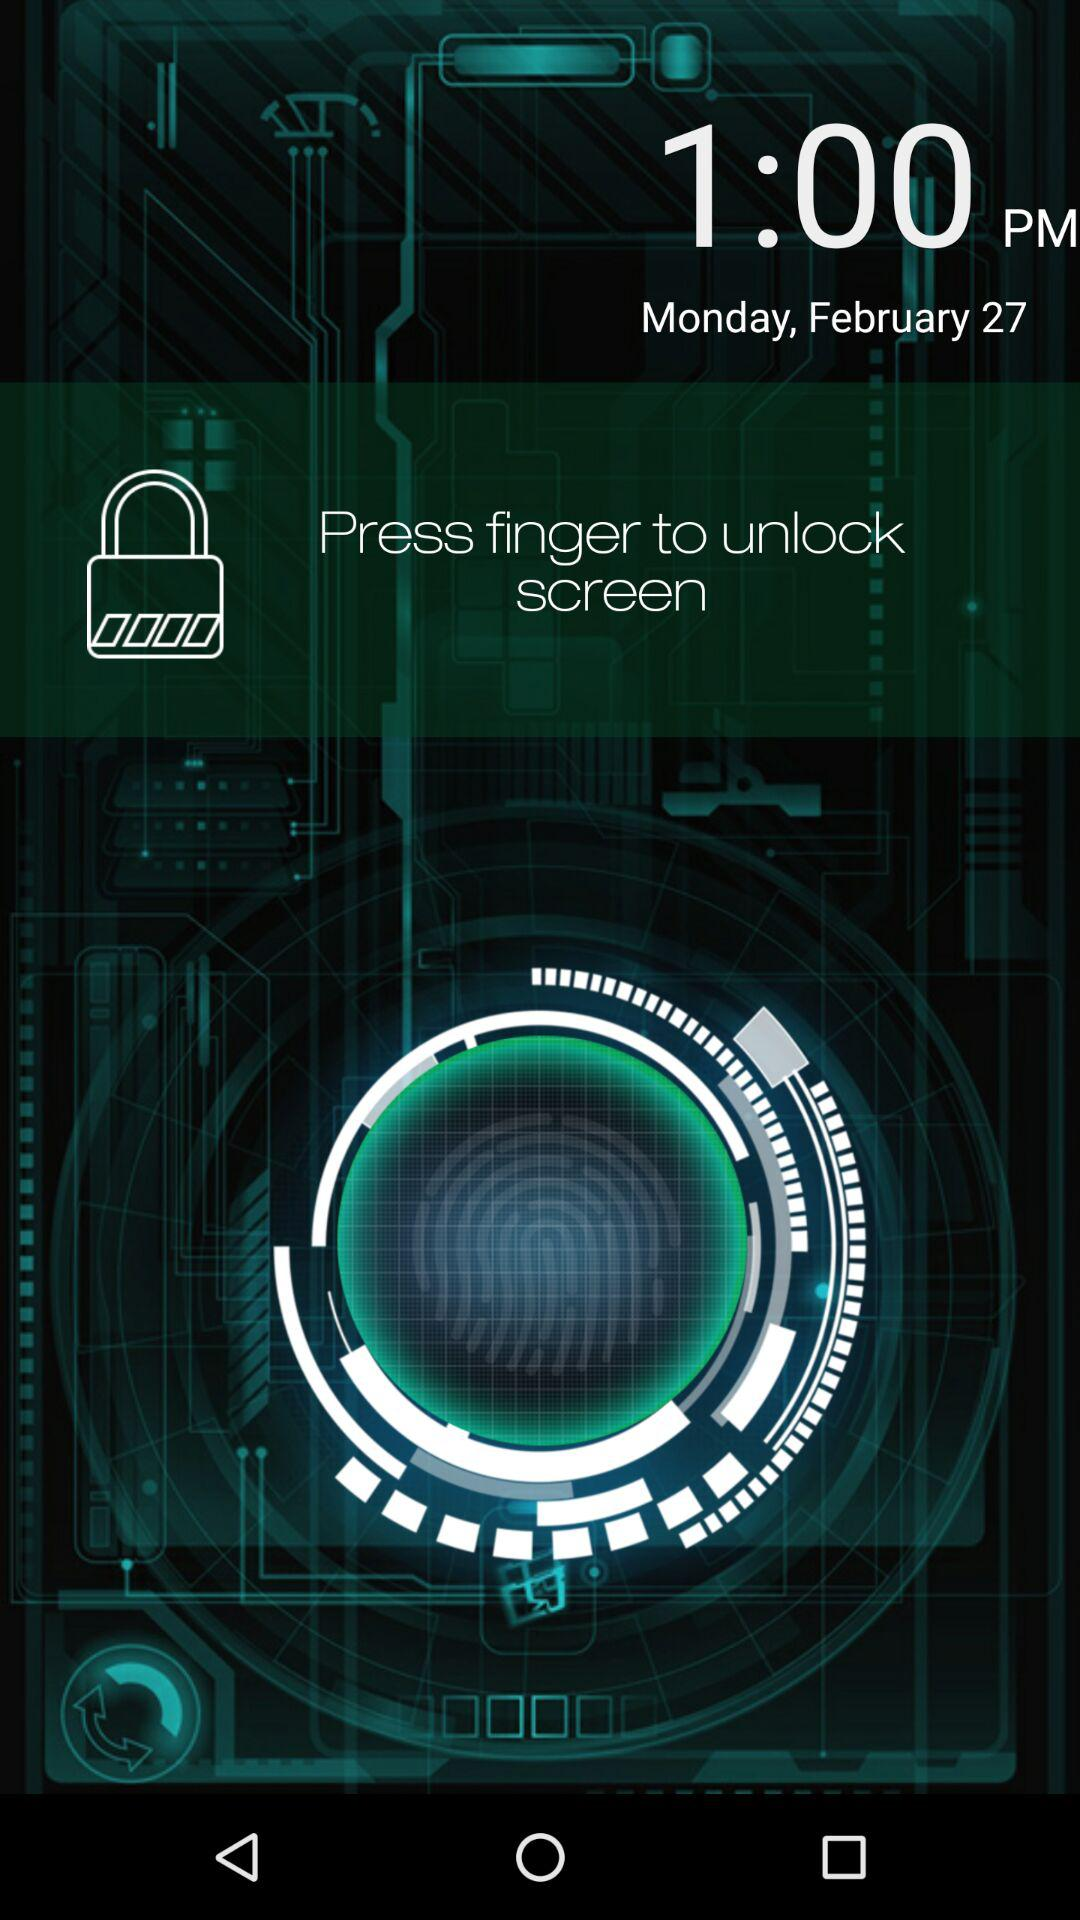What is the shown date? The shown date is Monday, February 27. 